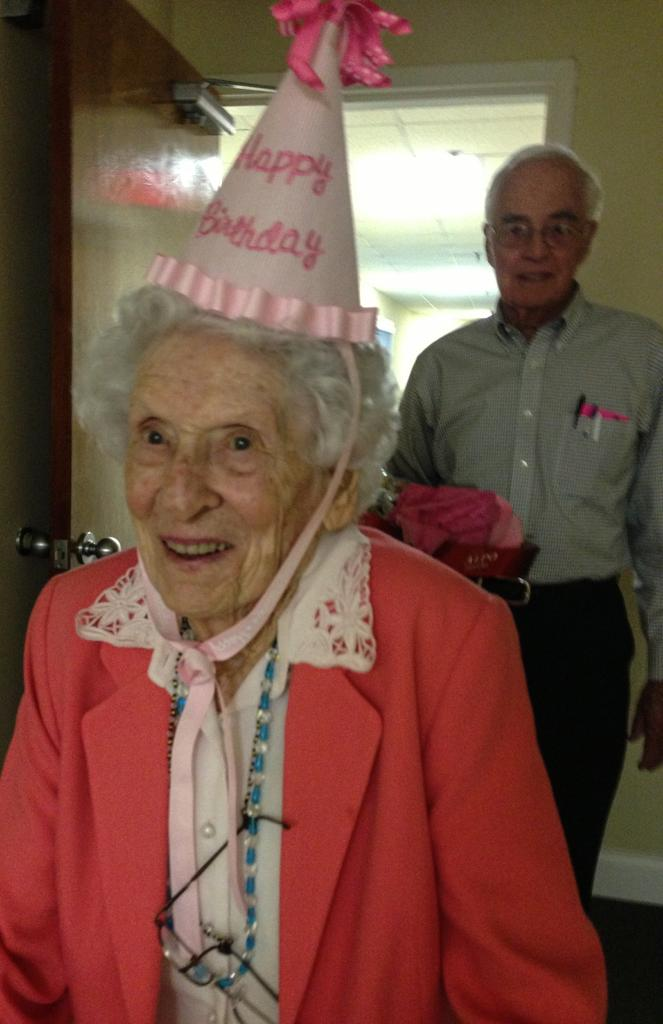How many people are in the image, and what are they wearing? There are two people with different color dresses in the image. Can you identify any specific accessory worn by one of the people? Yes, one person is wearing a birthday-cap. What can be seen in the background of the image? There is a door visible in the background of the image. What is visible at the top of the image? The ceiling is visible at the top of the image. What type of smell can be detected in the image? There is no information about any smell in the image, so it cannot be determined from the image. 